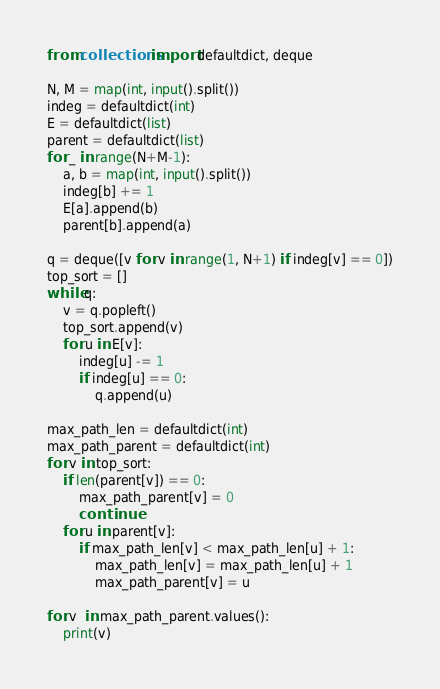Convert code to text. <code><loc_0><loc_0><loc_500><loc_500><_Python_>from collections import defaultdict, deque

N, M = map(int, input().split())
indeg = defaultdict(int)
E = defaultdict(list)
parent = defaultdict(list)
for _ in range(N+M-1):
    a, b = map(int, input().split())
    indeg[b] += 1
    E[a].append(b)
    parent[b].append(a)

q = deque([v for v in range(1, N+1) if indeg[v] == 0])
top_sort = []
while q:
    v = q.popleft()
    top_sort.append(v)
    for u in E[v]:
        indeg[u] -= 1
        if indeg[u] == 0:
            q.append(u)
            
max_path_len = defaultdict(int)
max_path_parent = defaultdict(int)
for v in top_sort:
    if len(parent[v]) == 0:
        max_path_parent[v] = 0
        continue
    for u in parent[v]:
        if max_path_len[v] < max_path_len[u] + 1:
            max_path_len[v] = max_path_len[u] + 1
            max_path_parent[v] = u

for v  in max_path_parent.values():
    print(v)</code> 